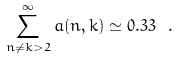<formula> <loc_0><loc_0><loc_500><loc_500>\sum _ { n \neq k > 2 } ^ { \infty } a ( n , k ) \simeq 0 . 3 3 \ .</formula> 